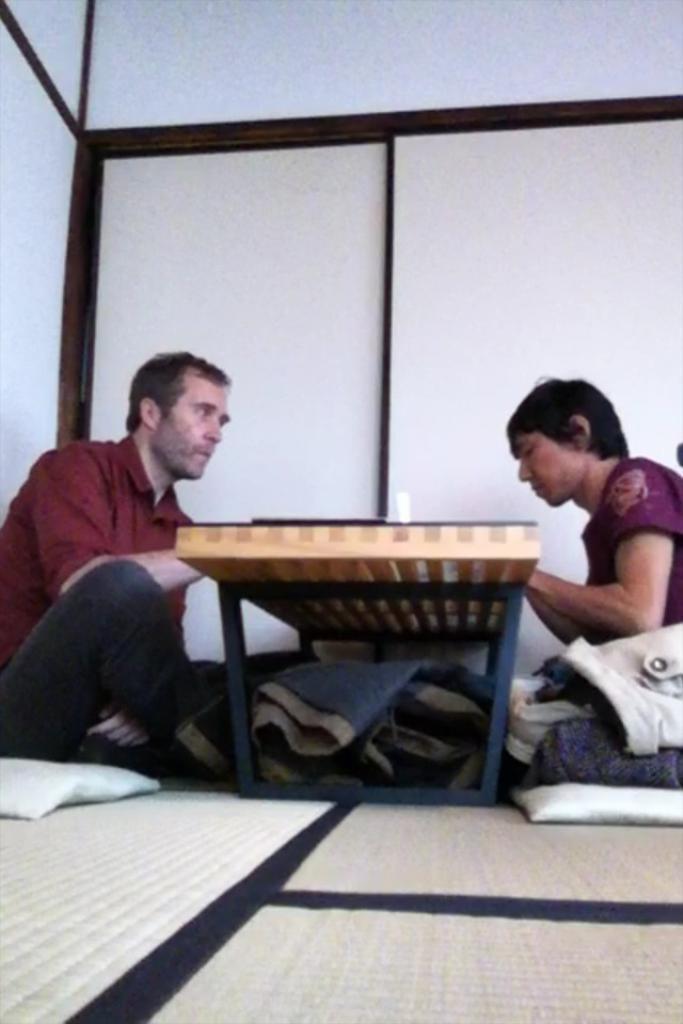Can you describe this image briefly? In picture describe about the inner view of the room in which two persons are sitting down, Right site sitting man wearing red color t- shirt and a wooden iron table between them. On the left side another man with purple color t- shirt , Behind we can see wardrobe doors. 